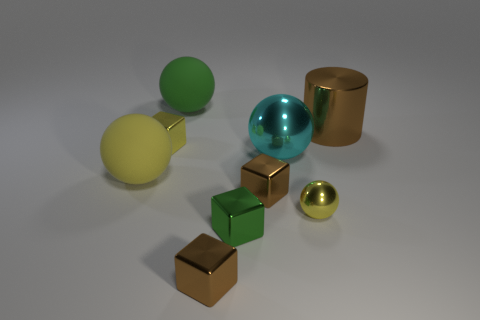Subtract 2 balls. How many balls are left? 2 Subtract all green cubes. How many cubes are left? 3 Subtract all tiny yellow metallic cubes. How many cubes are left? 3 Subtract all brown balls. Subtract all green cubes. How many balls are left? 4 Add 1 large yellow things. How many objects exist? 10 Subtract all blocks. How many objects are left? 5 Add 3 small brown blocks. How many small brown blocks are left? 5 Add 6 yellow metal spheres. How many yellow metal spheres exist? 7 Subtract 1 green cubes. How many objects are left? 8 Subtract all small brown blocks. Subtract all green cubes. How many objects are left? 6 